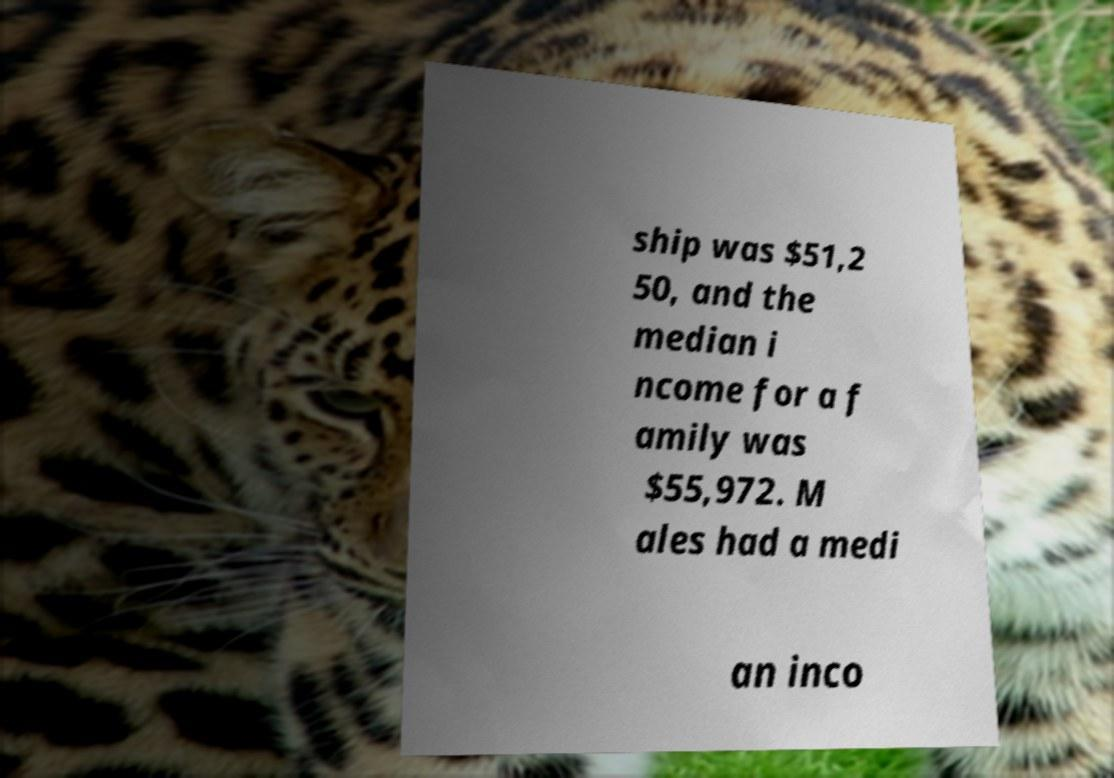Please read and relay the text visible in this image. What does it say? ship was $51,2 50, and the median i ncome for a f amily was $55,972. M ales had a medi an inco 